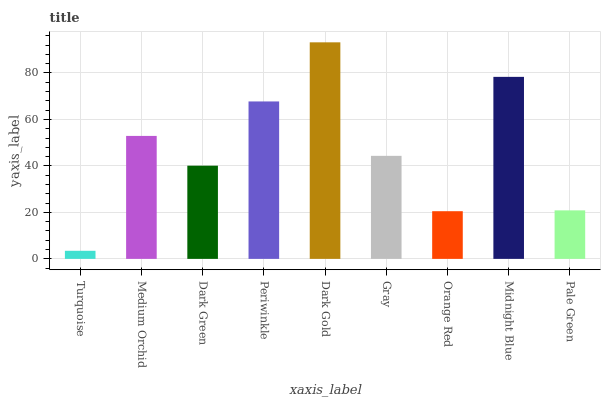Is Turquoise the minimum?
Answer yes or no. Yes. Is Dark Gold the maximum?
Answer yes or no. Yes. Is Medium Orchid the minimum?
Answer yes or no. No. Is Medium Orchid the maximum?
Answer yes or no. No. Is Medium Orchid greater than Turquoise?
Answer yes or no. Yes. Is Turquoise less than Medium Orchid?
Answer yes or no. Yes. Is Turquoise greater than Medium Orchid?
Answer yes or no. No. Is Medium Orchid less than Turquoise?
Answer yes or no. No. Is Gray the high median?
Answer yes or no. Yes. Is Gray the low median?
Answer yes or no. Yes. Is Midnight Blue the high median?
Answer yes or no. No. Is Dark Green the low median?
Answer yes or no. No. 